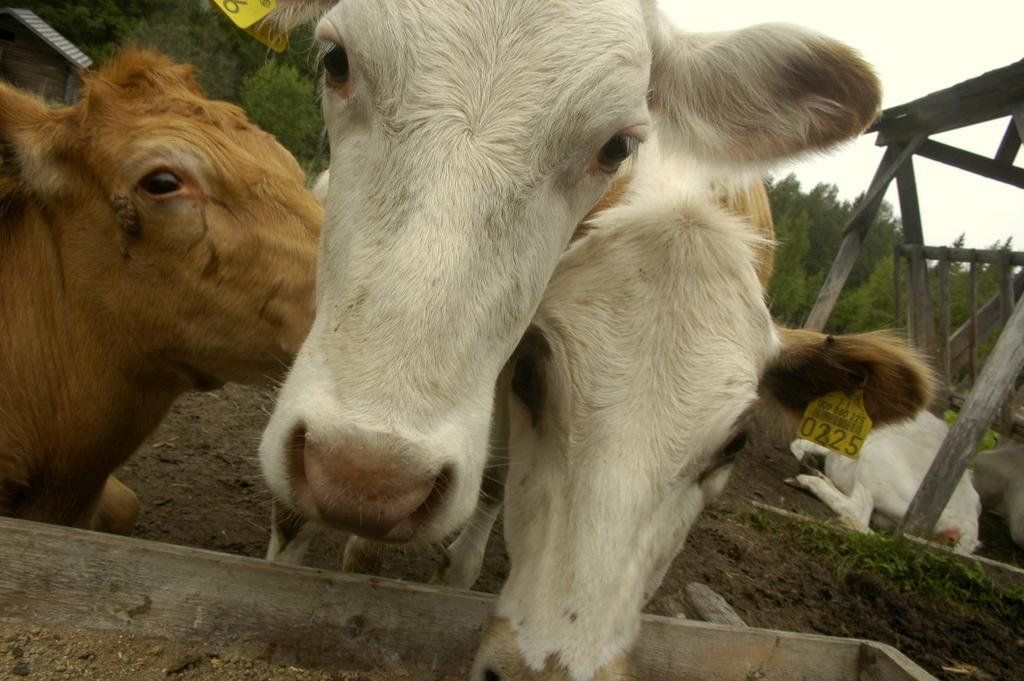How many cows are present in the image? There are three cows standing in the image. What is the wooden object in the image? The fact does not specify the nature of the wooden object, so we cannot describe it. What is the position of one of the cows in the image? There is a cow sitting in the image. What type of vegetation is visible in the image? There is grass visible in the image. What else can be seen in the image besides the cows and grass? There are trees and tags visible in the image. Is the grass in the image affected by the heat? The fact does not mention any heat in the image, so we cannot determine if the grass is affected by it. 